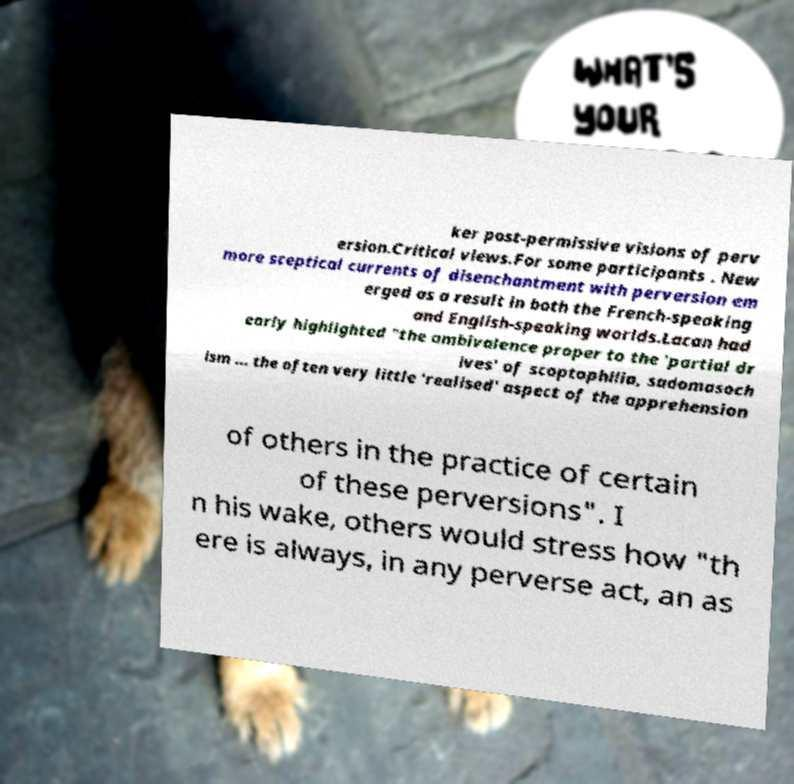Could you extract and type out the text from this image? ker post-permissive visions of perv ersion.Critical views.For some participants . New more sceptical currents of disenchantment with perversion em erged as a result in both the French-speaking and English-speaking worlds.Lacan had early highlighted "the ambivalence proper to the 'partial dr ives' of scoptophilia, sadomasoch ism ... the often very little 'realised' aspect of the apprehension of others in the practice of certain of these perversions". I n his wake, others would stress how "th ere is always, in any perverse act, an as 